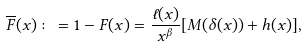<formula> <loc_0><loc_0><loc_500><loc_500>\overline { F } ( x ) \colon = 1 - F ( x ) = \frac { \ell ( x ) } { x ^ { \beta } } [ M ( \delta ( x ) ) + h ( x ) ] ,</formula> 